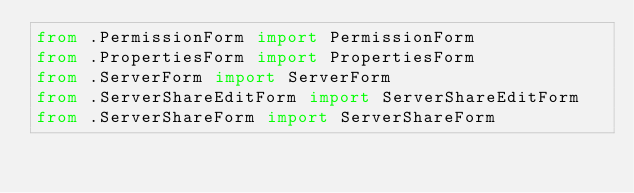Convert code to text. <code><loc_0><loc_0><loc_500><loc_500><_Python_>from .PermissionForm import PermissionForm
from .PropertiesForm import PropertiesForm
from .ServerForm import ServerForm
from .ServerShareEditForm import ServerShareEditForm
from .ServerShareForm import ServerShareForm
</code> 